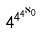<formula> <loc_0><loc_0><loc_500><loc_500>4 ^ { 4 ^ { 4 ^ { \aleph _ { 0 } } } }</formula> 